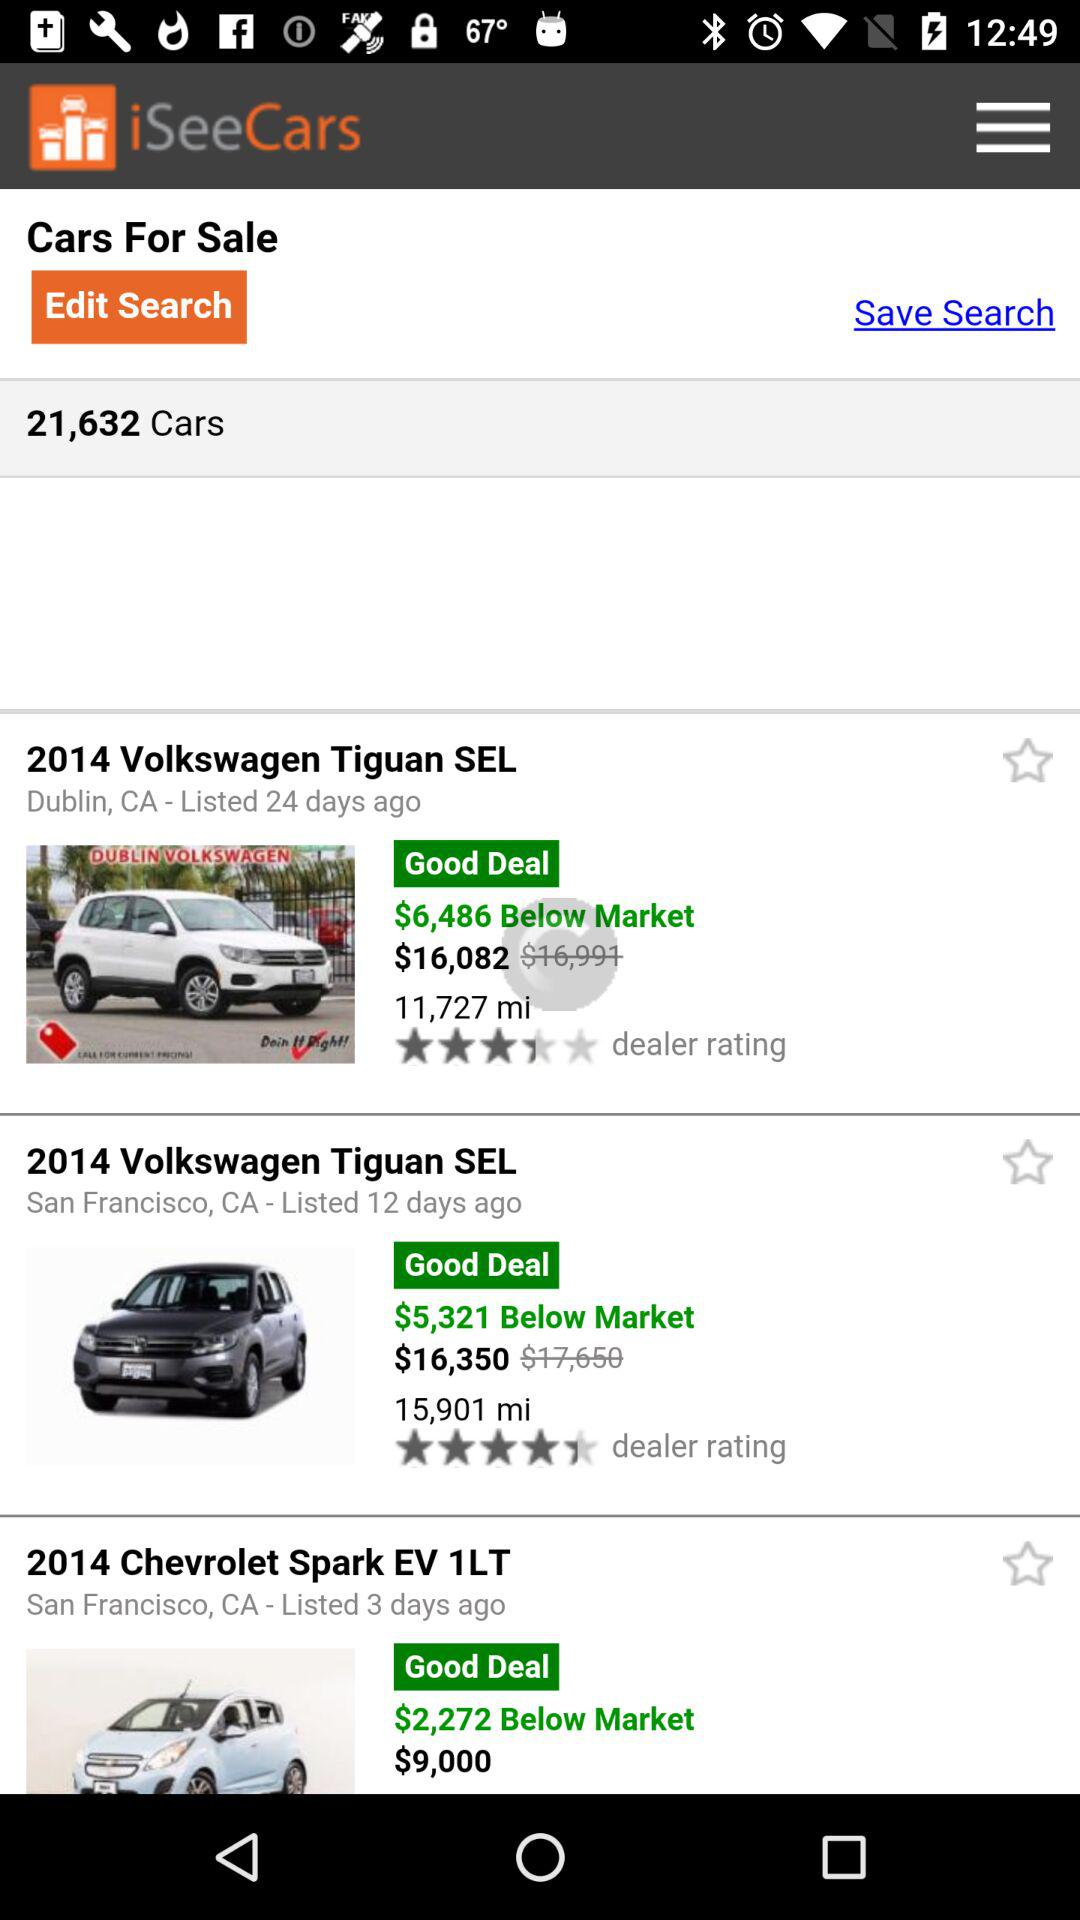How many days ago was "2014 Chevrolet Spark EV 1LT" listed? The "2014 Chevrolet Spark EV 1LT" was listed 3 days ago. 